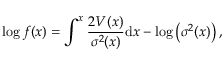<formula> <loc_0><loc_0><loc_500><loc_500>\log f ( x ) = \int ^ { x } \frac { 2 V ( x ) } { \sigma ^ { 2 } ( x ) } d x - \log \left ( \sigma ^ { 2 } ( x ) \right ) ,</formula> 